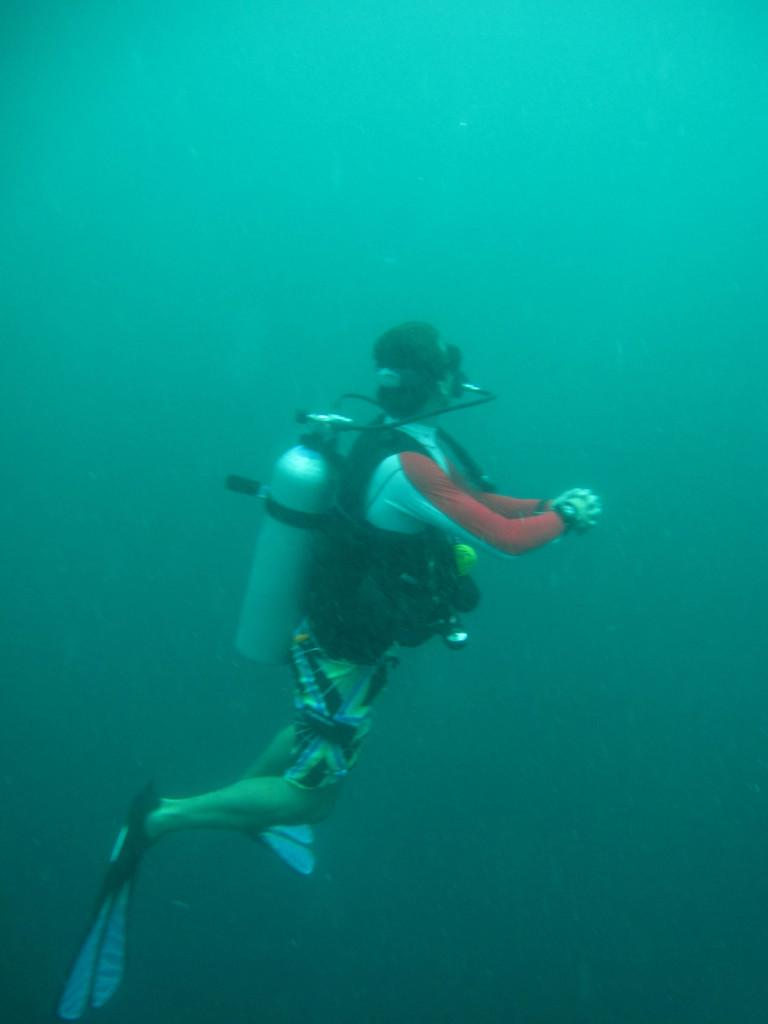What is the person in the image doing? The person is scuba diving. Where is the person located in the image? The person is in the water. What type of hair can be seen on the deer in the image? There is no deer present in the image, and therefore no hair can be observed. 